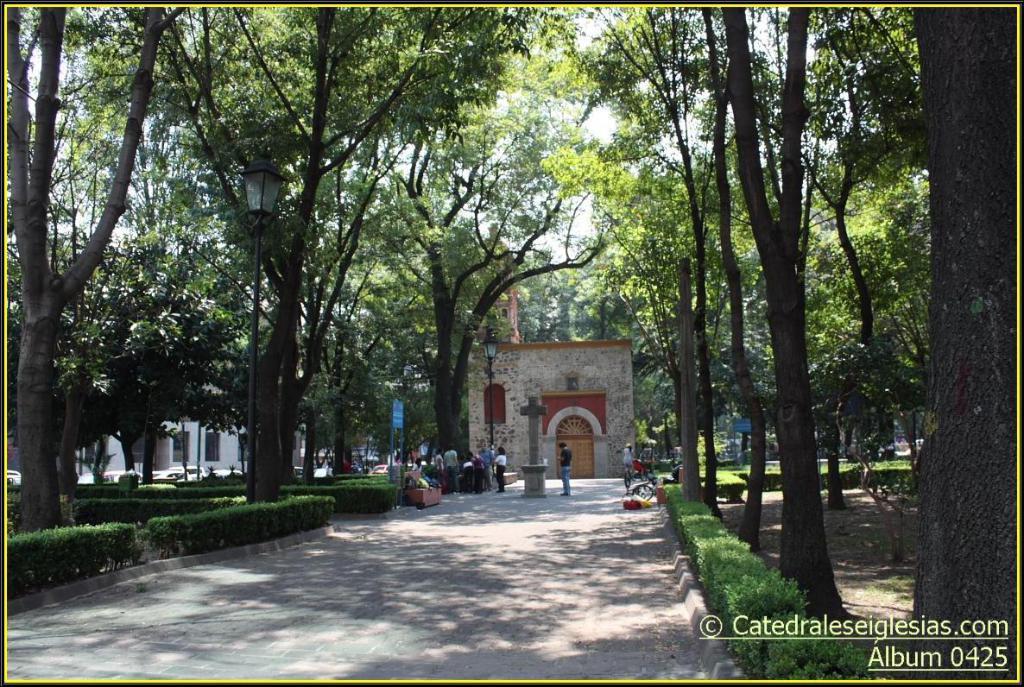Describe this image in one or two sentences. At the bottom of the image there is a road. There are few people standing on the road. And also there is a pedestal with a cross. Behind that there is a wall with doors and roofs. And in the image there are trees and also there are boards with text.  